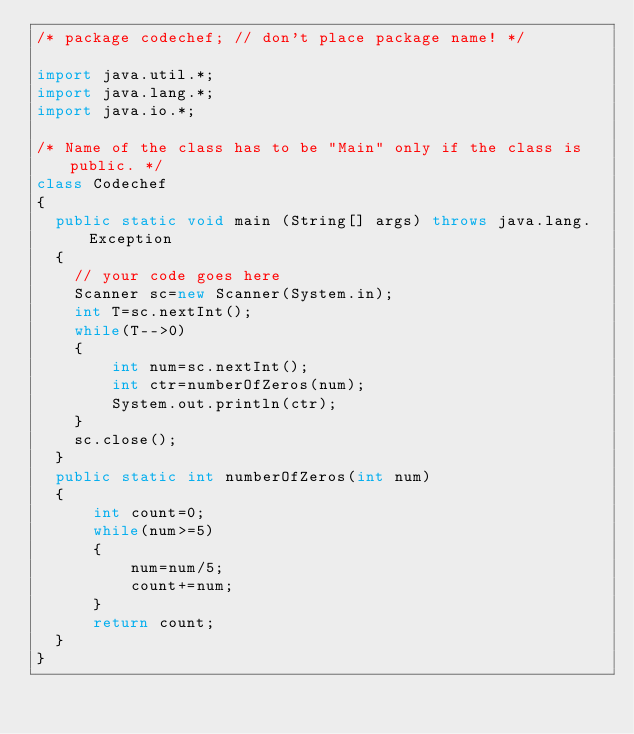<code> <loc_0><loc_0><loc_500><loc_500><_Java_>/* package codechef; // don't place package name! */

import java.util.*;
import java.lang.*;
import java.io.*;

/* Name of the class has to be "Main" only if the class is public. */
class Codechef
{
	public static void main (String[] args) throws java.lang.Exception
	{
		// your code goes here
		Scanner sc=new Scanner(System.in);
		int T=sc.nextInt();
		while(T-->0)
		{
		    int num=sc.nextInt();
		    int ctr=numberOfZeros(num);
		    System.out.println(ctr);
		}
		sc.close();
	}
	public static int numberOfZeros(int num)
	{
	    int count=0;
	    while(num>=5)
	    {
	        num=num/5;
	        count+=num;
	    }
	    return count;
	}
}
</code> 